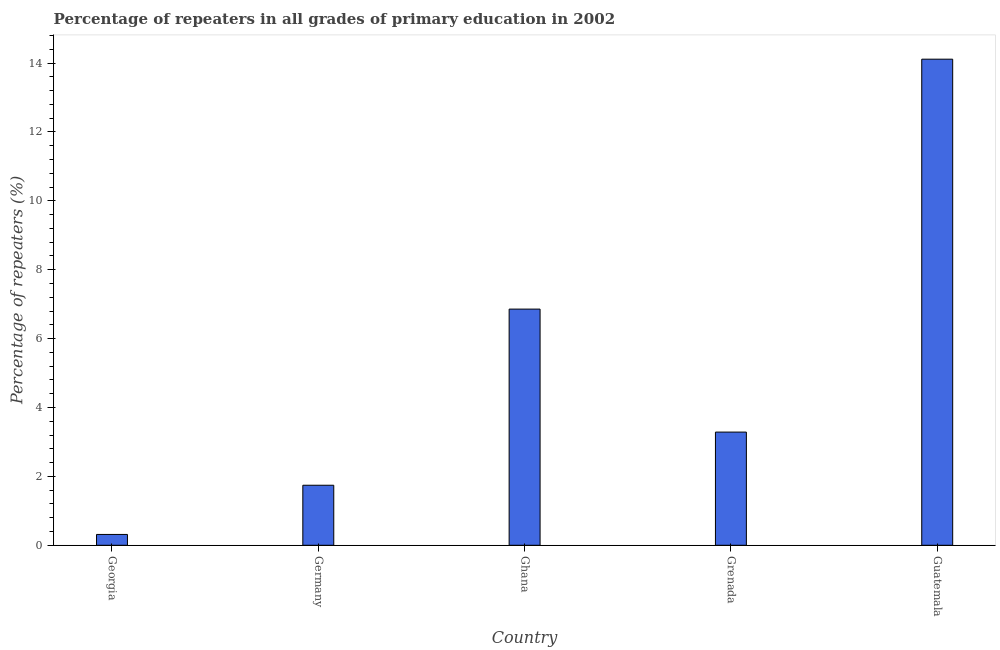Does the graph contain any zero values?
Your answer should be very brief. No. What is the title of the graph?
Your response must be concise. Percentage of repeaters in all grades of primary education in 2002. What is the label or title of the Y-axis?
Your answer should be compact. Percentage of repeaters (%). What is the percentage of repeaters in primary education in Guatemala?
Offer a very short reply. 14.11. Across all countries, what is the maximum percentage of repeaters in primary education?
Your answer should be compact. 14.11. Across all countries, what is the minimum percentage of repeaters in primary education?
Make the answer very short. 0.31. In which country was the percentage of repeaters in primary education maximum?
Provide a succinct answer. Guatemala. In which country was the percentage of repeaters in primary education minimum?
Make the answer very short. Georgia. What is the sum of the percentage of repeaters in primary education?
Offer a terse response. 26.31. What is the difference between the percentage of repeaters in primary education in Germany and Guatemala?
Your response must be concise. -12.37. What is the average percentage of repeaters in primary education per country?
Your answer should be very brief. 5.26. What is the median percentage of repeaters in primary education?
Give a very brief answer. 3.29. What is the ratio of the percentage of repeaters in primary education in Georgia to that in Grenada?
Ensure brevity in your answer.  0.1. Is the percentage of repeaters in primary education in Georgia less than that in Guatemala?
Provide a succinct answer. Yes. Is the difference between the percentage of repeaters in primary education in Ghana and Guatemala greater than the difference between any two countries?
Make the answer very short. No. What is the difference between the highest and the second highest percentage of repeaters in primary education?
Make the answer very short. 7.25. Is the sum of the percentage of repeaters in primary education in Ghana and Guatemala greater than the maximum percentage of repeaters in primary education across all countries?
Ensure brevity in your answer.  Yes. What is the difference between the highest and the lowest percentage of repeaters in primary education?
Offer a very short reply. 13.8. How many bars are there?
Offer a terse response. 5. Are all the bars in the graph horizontal?
Offer a terse response. No. How many countries are there in the graph?
Make the answer very short. 5. What is the difference between two consecutive major ticks on the Y-axis?
Give a very brief answer. 2. Are the values on the major ticks of Y-axis written in scientific E-notation?
Your answer should be very brief. No. What is the Percentage of repeaters (%) in Georgia?
Your answer should be compact. 0.31. What is the Percentage of repeaters (%) of Germany?
Your answer should be compact. 1.74. What is the Percentage of repeaters (%) of Ghana?
Give a very brief answer. 6.86. What is the Percentage of repeaters (%) in Grenada?
Ensure brevity in your answer.  3.29. What is the Percentage of repeaters (%) in Guatemala?
Your answer should be compact. 14.11. What is the difference between the Percentage of repeaters (%) in Georgia and Germany?
Provide a succinct answer. -1.43. What is the difference between the Percentage of repeaters (%) in Georgia and Ghana?
Ensure brevity in your answer.  -6.54. What is the difference between the Percentage of repeaters (%) in Georgia and Grenada?
Your answer should be compact. -2.97. What is the difference between the Percentage of repeaters (%) in Georgia and Guatemala?
Your answer should be compact. -13.8. What is the difference between the Percentage of repeaters (%) in Germany and Ghana?
Offer a very short reply. -5.11. What is the difference between the Percentage of repeaters (%) in Germany and Grenada?
Your answer should be very brief. -1.54. What is the difference between the Percentage of repeaters (%) in Germany and Guatemala?
Ensure brevity in your answer.  -12.37. What is the difference between the Percentage of repeaters (%) in Ghana and Grenada?
Offer a very short reply. 3.57. What is the difference between the Percentage of repeaters (%) in Ghana and Guatemala?
Make the answer very short. -7.26. What is the difference between the Percentage of repeaters (%) in Grenada and Guatemala?
Make the answer very short. -10.83. What is the ratio of the Percentage of repeaters (%) in Georgia to that in Germany?
Offer a terse response. 0.18. What is the ratio of the Percentage of repeaters (%) in Georgia to that in Ghana?
Keep it short and to the point. 0.05. What is the ratio of the Percentage of repeaters (%) in Georgia to that in Grenada?
Offer a terse response. 0.1. What is the ratio of the Percentage of repeaters (%) in Georgia to that in Guatemala?
Make the answer very short. 0.02. What is the ratio of the Percentage of repeaters (%) in Germany to that in Ghana?
Your answer should be compact. 0.25. What is the ratio of the Percentage of repeaters (%) in Germany to that in Grenada?
Your answer should be very brief. 0.53. What is the ratio of the Percentage of repeaters (%) in Germany to that in Guatemala?
Keep it short and to the point. 0.12. What is the ratio of the Percentage of repeaters (%) in Ghana to that in Grenada?
Offer a terse response. 2.09. What is the ratio of the Percentage of repeaters (%) in Ghana to that in Guatemala?
Your answer should be compact. 0.49. What is the ratio of the Percentage of repeaters (%) in Grenada to that in Guatemala?
Offer a terse response. 0.23. 